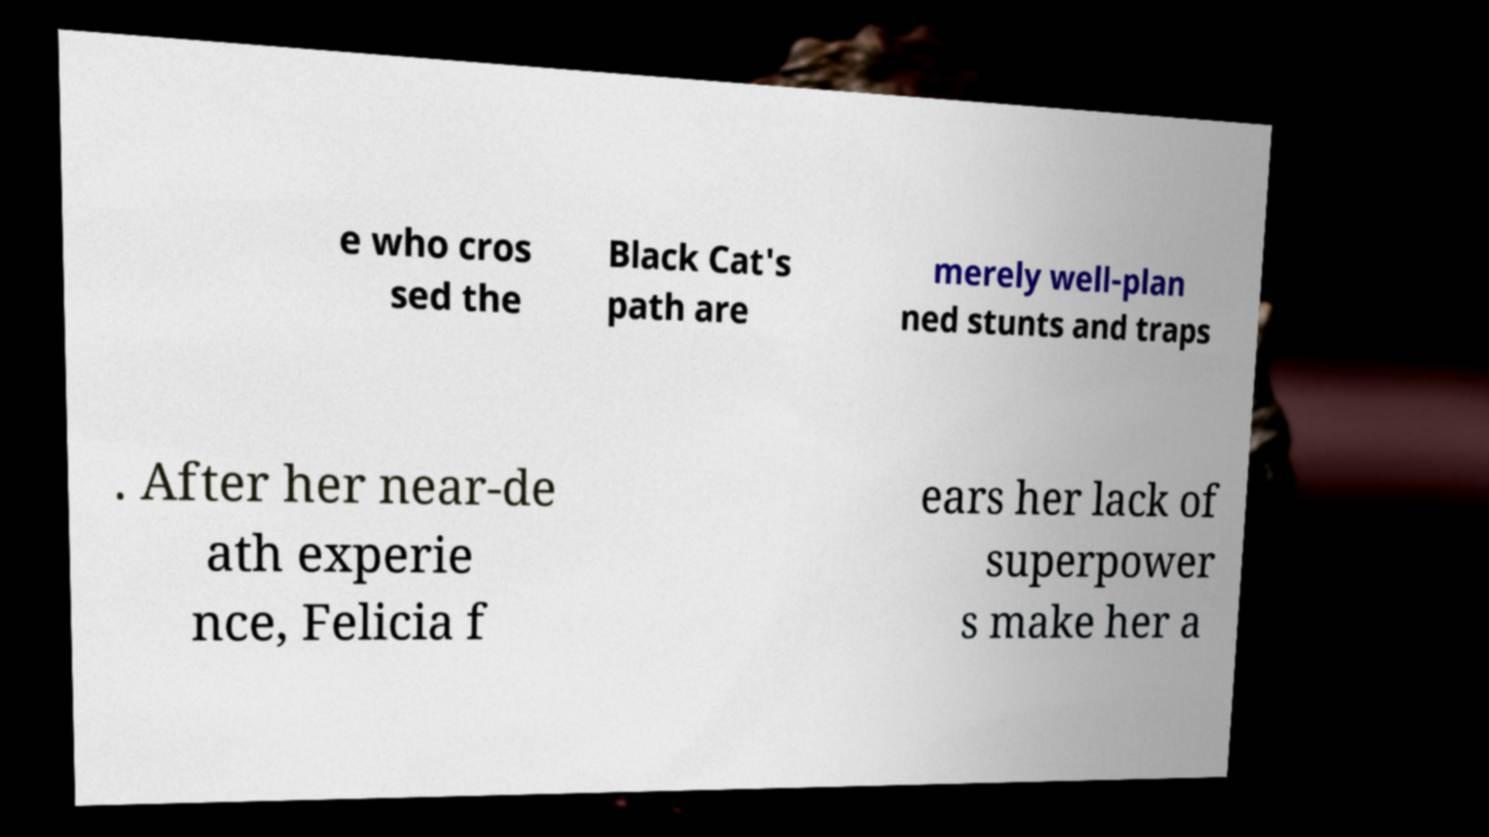There's text embedded in this image that I need extracted. Can you transcribe it verbatim? e who cros sed the Black Cat's path are merely well-plan ned stunts and traps . After her near-de ath experie nce, Felicia f ears her lack of superpower s make her a 